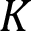<formula> <loc_0><loc_0><loc_500><loc_500>K</formula> 